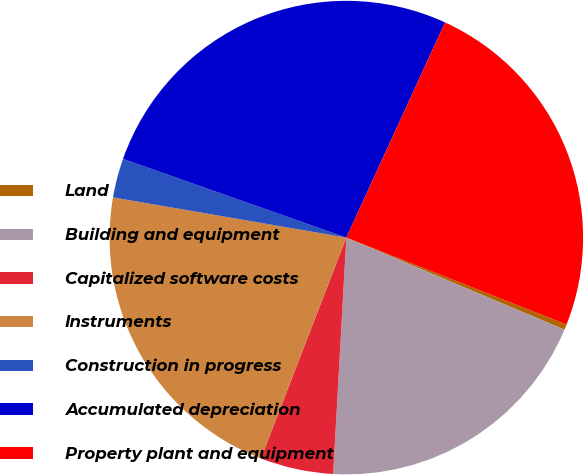Convert chart to OTSL. <chart><loc_0><loc_0><loc_500><loc_500><pie_chart><fcel>Land<fcel>Building and equipment<fcel>Capitalized software costs<fcel>Instruments<fcel>Construction in progress<fcel>Accumulated depreciation<fcel>Property plant and equipment<nl><fcel>0.37%<fcel>19.53%<fcel>4.99%<fcel>21.84%<fcel>2.68%<fcel>26.45%<fcel>24.14%<nl></chart> 